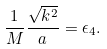Convert formula to latex. <formula><loc_0><loc_0><loc_500><loc_500>\frac { 1 } { M } \frac { \sqrt { { k } ^ { 2 } } } { a } = \epsilon _ { 4 } .</formula> 